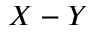Convert formula to latex. <formula><loc_0><loc_0><loc_500><loc_500>X - Y</formula> 